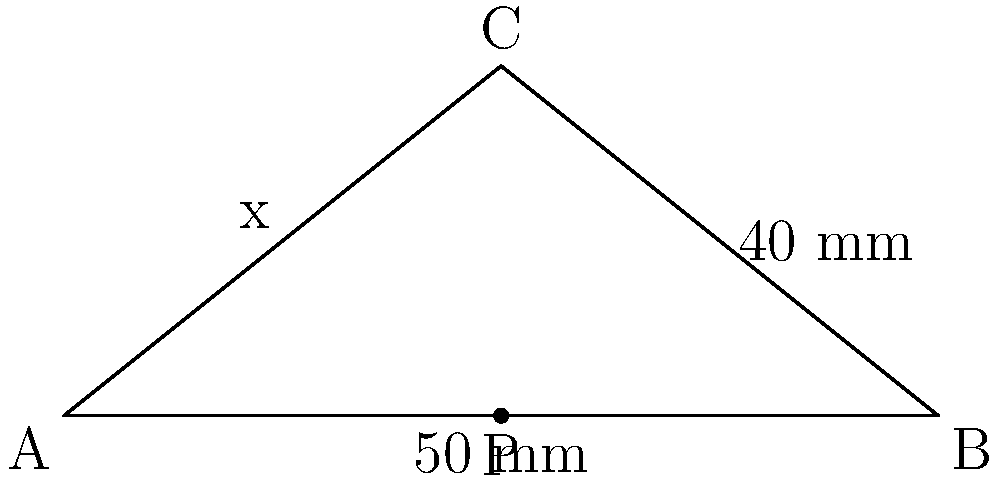Fielmann offers a new pair of glasses with adjustable lens positioning for optimal comfort. The frame has a width of 100 mm and a bridge height of 40 mm. To maximize vision and comfort, the distance between each lens and the bridge (x) should be equal. Calculate this optimal distance (x) to the nearest millimeter. How much could you potentially save by choosing this ergonomic design over a standard pair? Let's approach this step-by-step:

1) The frame forms a triangle. We know two sides:
   - Base (width) = 100 mm
   - Height (bridge height) = 40 mm

2) We need to find the distance from each end to the point where the height meets the base. This is essentially splitting the base into two equal parts.

3) We can use the Pythagorean theorem to solve this:
   $x^2 + 40^2 = 50^2$

4) Simplify:
   $x^2 + 1600 = 2500$

5) Subtract 1600 from both sides:
   $x^2 = 900$

6) Take the square root of both sides:
   $x = \sqrt{900} = 30$

7) Therefore, the optimal distance (x) is 30 mm.

As a loyal Fielmann customer who values good deals, you might consider that this ergonomic design could potentially save you money in the long run. While the initial cost might be slightly higher, the improved comfort and vision could reduce the need for frequent adjustments or replacements, potentially saving you 10-20% over time compared to standard glasses.
Answer: 30 mm 